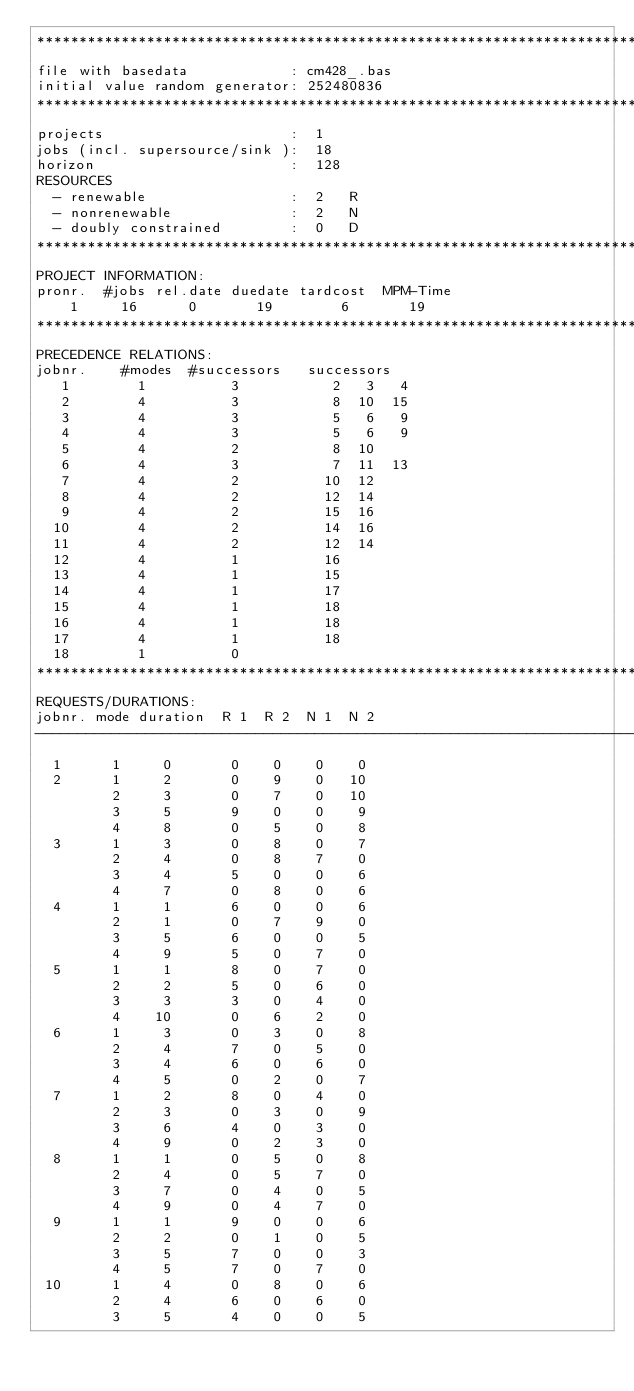Convert code to text. <code><loc_0><loc_0><loc_500><loc_500><_ObjectiveC_>************************************************************************
file with basedata            : cm428_.bas
initial value random generator: 252480836
************************************************************************
projects                      :  1
jobs (incl. supersource/sink ):  18
horizon                       :  128
RESOURCES
  - renewable                 :  2   R
  - nonrenewable              :  2   N
  - doubly constrained        :  0   D
************************************************************************
PROJECT INFORMATION:
pronr.  #jobs rel.date duedate tardcost  MPM-Time
    1     16      0       19        6       19
************************************************************************
PRECEDENCE RELATIONS:
jobnr.    #modes  #successors   successors
   1        1          3           2   3   4
   2        4          3           8  10  15
   3        4          3           5   6   9
   4        4          3           5   6   9
   5        4          2           8  10
   6        4          3           7  11  13
   7        4          2          10  12
   8        4          2          12  14
   9        4          2          15  16
  10        4          2          14  16
  11        4          2          12  14
  12        4          1          16
  13        4          1          15
  14        4          1          17
  15        4          1          18
  16        4          1          18
  17        4          1          18
  18        1          0        
************************************************************************
REQUESTS/DURATIONS:
jobnr. mode duration  R 1  R 2  N 1  N 2
------------------------------------------------------------------------
  1      1     0       0    0    0    0
  2      1     2       0    9    0   10
         2     3       0    7    0   10
         3     5       9    0    0    9
         4     8       0    5    0    8
  3      1     3       0    8    0    7
         2     4       0    8    7    0
         3     4       5    0    0    6
         4     7       0    8    0    6
  4      1     1       6    0    0    6
         2     1       0    7    9    0
         3     5       6    0    0    5
         4     9       5    0    7    0
  5      1     1       8    0    7    0
         2     2       5    0    6    0
         3     3       3    0    4    0
         4    10       0    6    2    0
  6      1     3       0    3    0    8
         2     4       7    0    5    0
         3     4       6    0    6    0
         4     5       0    2    0    7
  7      1     2       8    0    4    0
         2     3       0    3    0    9
         3     6       4    0    3    0
         4     9       0    2    3    0
  8      1     1       0    5    0    8
         2     4       0    5    7    0
         3     7       0    4    0    5
         4     9       0    4    7    0
  9      1     1       9    0    0    6
         2     2       0    1    0    5
         3     5       7    0    0    3
         4     5       7    0    7    0
 10      1     4       0    8    0    6
         2     4       6    0    6    0
         3     5       4    0    0    5</code> 